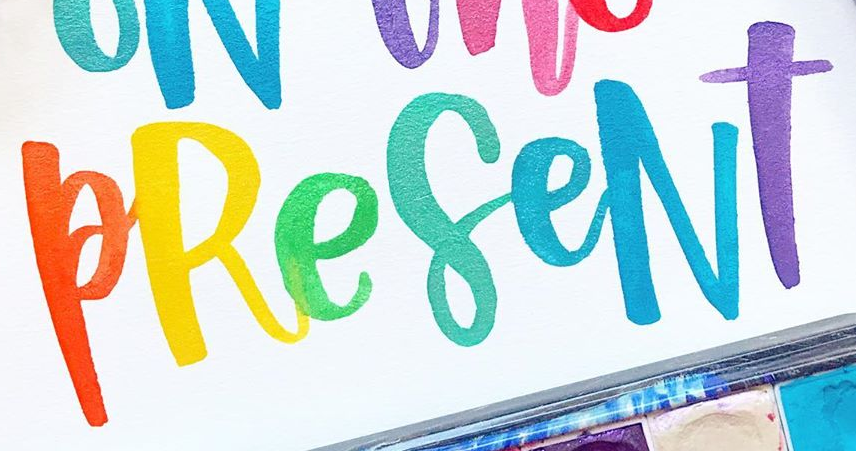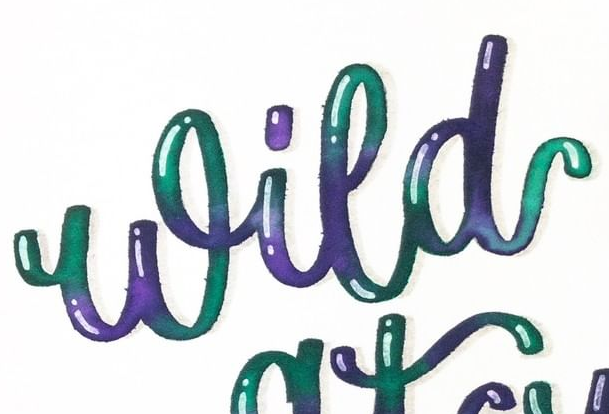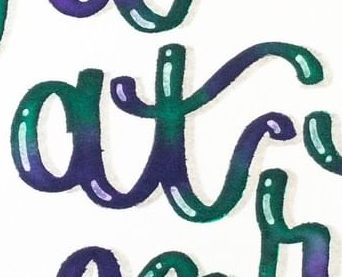What words can you see in these images in sequence, separated by a semicolon? PReseNT; Wild; at 